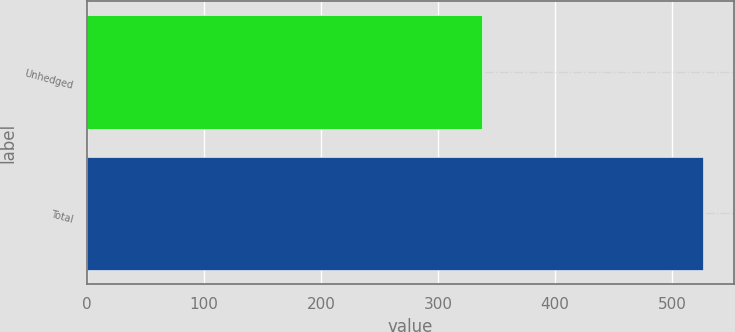Convert chart. <chart><loc_0><loc_0><loc_500><loc_500><bar_chart><fcel>Unhedged<fcel>Total<nl><fcel>338<fcel>527<nl></chart> 